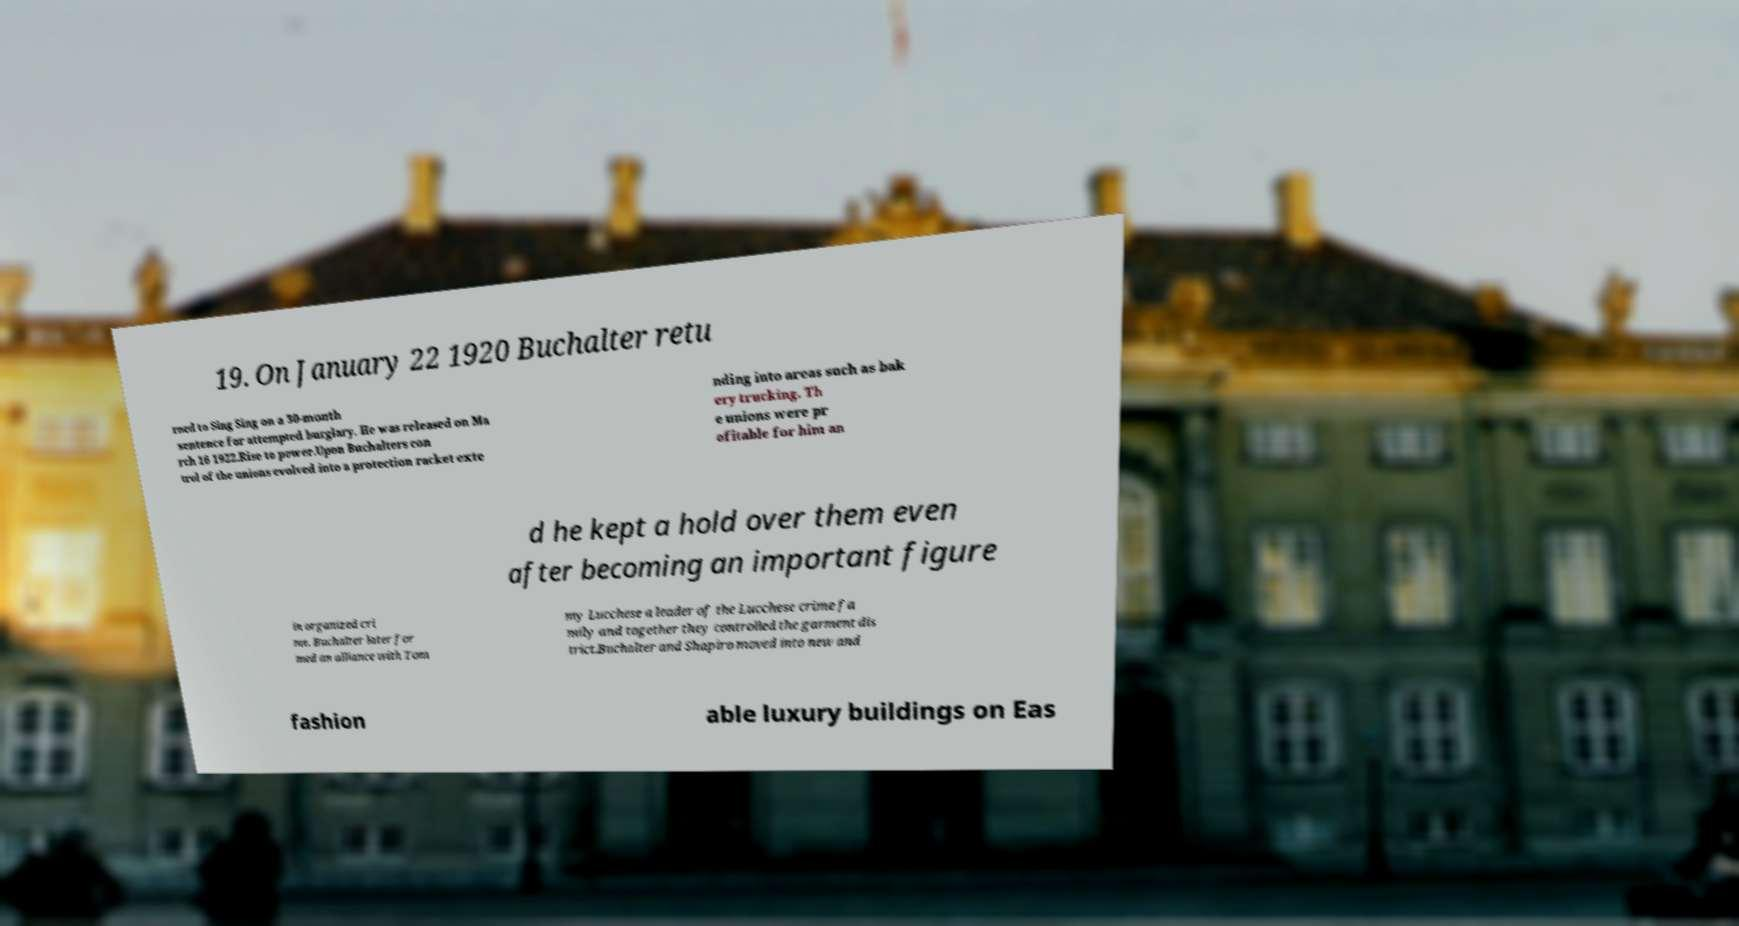There's text embedded in this image that I need extracted. Can you transcribe it verbatim? 19. On January 22 1920 Buchalter retu rned to Sing Sing on a 30-month sentence for attempted burglary. He was released on Ma rch 16 1922.Rise to power.Upon Buchalters con trol of the unions evolved into a protection racket exte nding into areas such as bak ery trucking. Th e unions were pr ofitable for him an d he kept a hold over them even after becoming an important figure in organized cri me. Buchalter later for med an alliance with Tom my Lucchese a leader of the Lucchese crime fa mily and together they controlled the garment dis trict.Buchalter and Shapiro moved into new and fashion able luxury buildings on Eas 